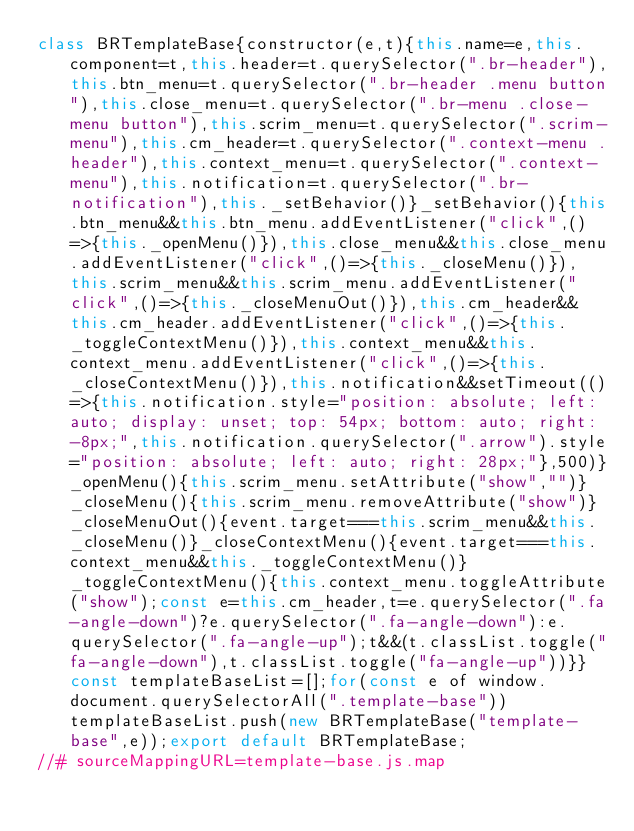<code> <loc_0><loc_0><loc_500><loc_500><_JavaScript_>class BRTemplateBase{constructor(e,t){this.name=e,this.component=t,this.header=t.querySelector(".br-header"),this.btn_menu=t.querySelector(".br-header .menu button"),this.close_menu=t.querySelector(".br-menu .close-menu button"),this.scrim_menu=t.querySelector(".scrim-menu"),this.cm_header=t.querySelector(".context-menu .header"),this.context_menu=t.querySelector(".context-menu"),this.notification=t.querySelector(".br-notification"),this._setBehavior()}_setBehavior(){this.btn_menu&&this.btn_menu.addEventListener("click",()=>{this._openMenu()}),this.close_menu&&this.close_menu.addEventListener("click",()=>{this._closeMenu()}),this.scrim_menu&&this.scrim_menu.addEventListener("click",()=>{this._closeMenuOut()}),this.cm_header&&this.cm_header.addEventListener("click",()=>{this._toggleContextMenu()}),this.context_menu&&this.context_menu.addEventListener("click",()=>{this._closeContextMenu()}),this.notification&&setTimeout(()=>{this.notification.style="position: absolute; left: auto; display: unset; top: 54px; bottom: auto; right: -8px;",this.notification.querySelector(".arrow").style="position: absolute; left: auto; right: 28px;"},500)}_openMenu(){this.scrim_menu.setAttribute("show","")}_closeMenu(){this.scrim_menu.removeAttribute("show")}_closeMenuOut(){event.target===this.scrim_menu&&this._closeMenu()}_closeContextMenu(){event.target===this.context_menu&&this._toggleContextMenu()}_toggleContextMenu(){this.context_menu.toggleAttribute("show");const e=this.cm_header,t=e.querySelector(".fa-angle-down")?e.querySelector(".fa-angle-down"):e.querySelector(".fa-angle-up");t&&(t.classList.toggle("fa-angle-down"),t.classList.toggle("fa-angle-up"))}}const templateBaseList=[];for(const e of window.document.querySelectorAll(".template-base"))templateBaseList.push(new BRTemplateBase("template-base",e));export default BRTemplateBase;
//# sourceMappingURL=template-base.js.map</code> 